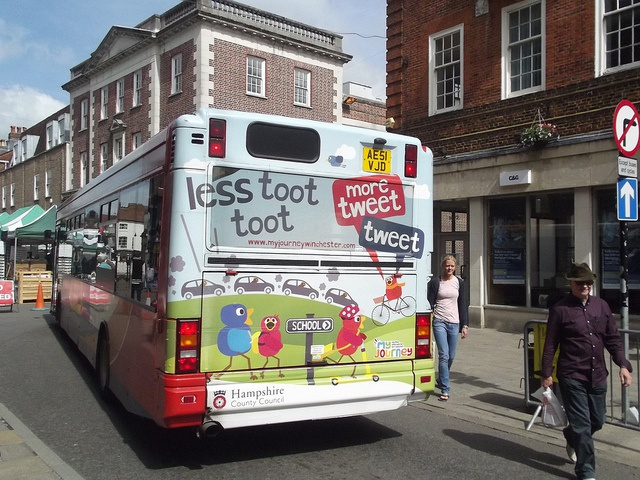Describe the objects in this image and their specific colors. I can see bus in darkgray, lightgray, black, and gray tones, people in darkgray, black, purple, and gray tones, and people in darkgray, black, lightgray, and gray tones in this image. 